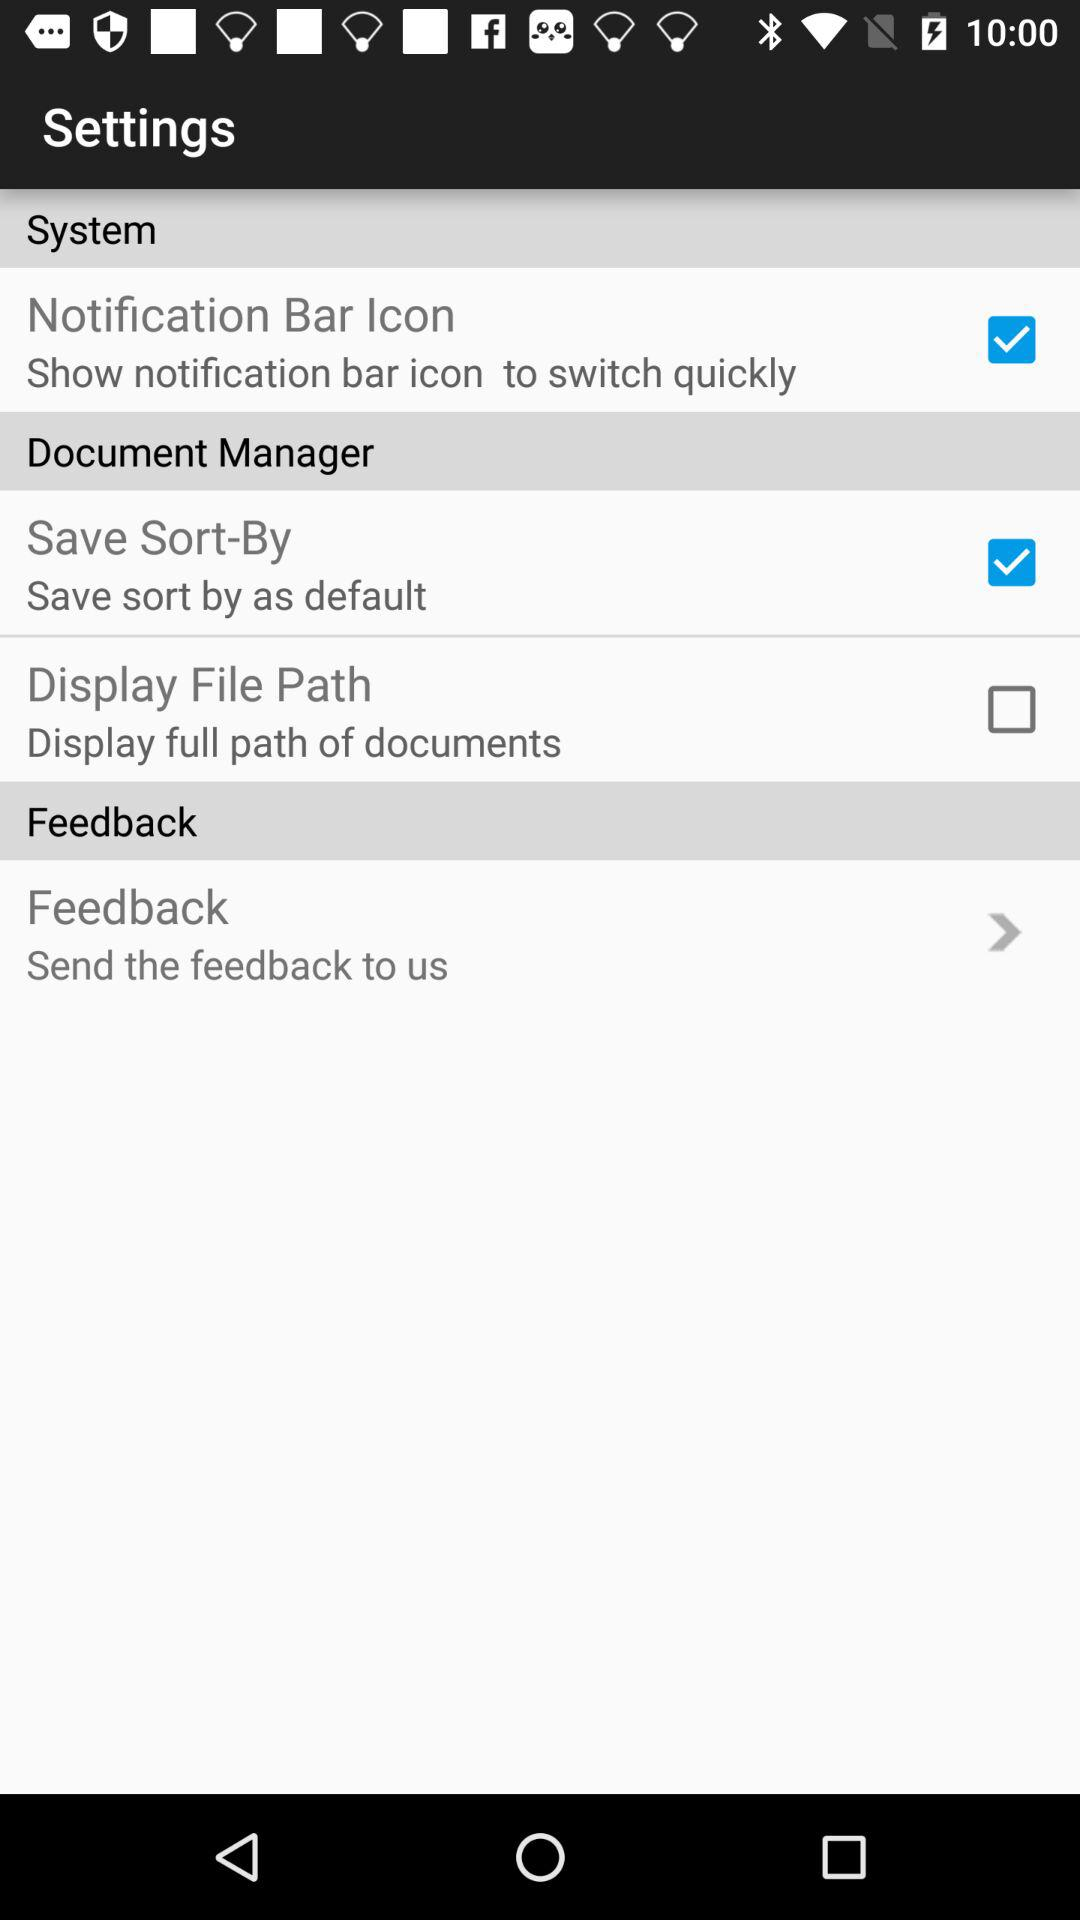Which options are checked? The checked options are "Notification Bar Icon" and "Save Sort-By". 